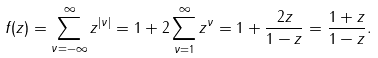<formula> <loc_0><loc_0><loc_500><loc_500>f ( z ) = \sum _ { \nu = - \infty } ^ { \infty } z ^ { | \nu | } = 1 + 2 \sum _ { \nu = 1 } ^ { \infty } z ^ { \nu } = 1 + \frac { 2 z } { 1 - z } = \frac { 1 + z } { 1 - z } .</formula> 